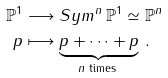<formula> <loc_0><loc_0><loc_500><loc_500>\mathbb { P } ^ { 1 } & \longrightarrow S y m ^ { n } \, \mathbb { P } ^ { 1 } \simeq \mathbb { P } ^ { n } \\ p & \longmapsto \underbrace { p + \cdots + p } _ { n \text { times } } \, .</formula> 